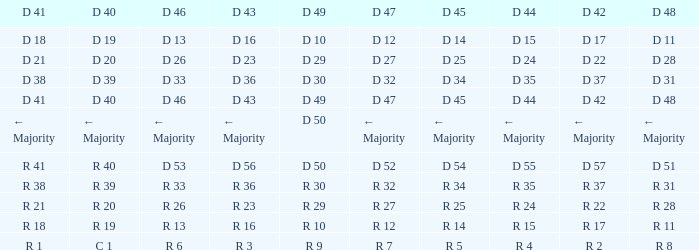I want the D 45 and D 42 of r 22 R 25. 